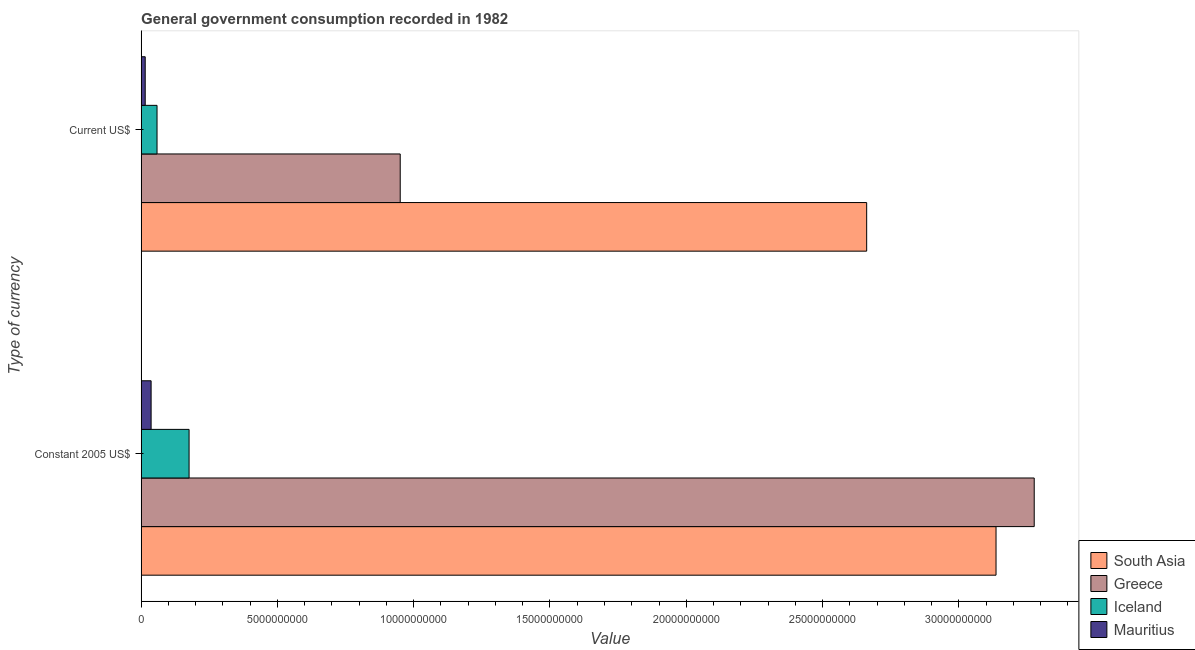How many different coloured bars are there?
Offer a terse response. 4. Are the number of bars on each tick of the Y-axis equal?
Provide a succinct answer. Yes. What is the label of the 2nd group of bars from the top?
Provide a succinct answer. Constant 2005 US$. What is the value consumed in current us$ in South Asia?
Your answer should be very brief. 2.66e+1. Across all countries, what is the maximum value consumed in constant 2005 us$?
Your answer should be very brief. 3.28e+1. Across all countries, what is the minimum value consumed in current us$?
Offer a terse response. 1.49e+08. In which country was the value consumed in constant 2005 us$ minimum?
Make the answer very short. Mauritius. What is the total value consumed in constant 2005 us$ in the graph?
Your answer should be compact. 6.63e+1. What is the difference between the value consumed in current us$ in Mauritius and that in Iceland?
Offer a terse response. -4.33e+08. What is the difference between the value consumed in current us$ in South Asia and the value consumed in constant 2005 us$ in Iceland?
Your answer should be compact. 2.49e+1. What is the average value consumed in current us$ per country?
Offer a terse response. 9.21e+09. What is the difference between the value consumed in current us$ and value consumed in constant 2005 us$ in Greece?
Provide a succinct answer. -2.33e+1. What is the ratio of the value consumed in current us$ in Greece to that in South Asia?
Keep it short and to the point. 0.36. Is the value consumed in constant 2005 us$ in Iceland less than that in South Asia?
Your response must be concise. Yes. In how many countries, is the value consumed in constant 2005 us$ greater than the average value consumed in constant 2005 us$ taken over all countries?
Provide a succinct answer. 2. What does the 3rd bar from the top in Constant 2005 US$ represents?
Make the answer very short. Greece. Are all the bars in the graph horizontal?
Offer a terse response. Yes. How many countries are there in the graph?
Your response must be concise. 4. What is the difference between two consecutive major ticks on the X-axis?
Make the answer very short. 5.00e+09. Are the values on the major ticks of X-axis written in scientific E-notation?
Ensure brevity in your answer.  No. Does the graph contain any zero values?
Keep it short and to the point. No. Does the graph contain grids?
Make the answer very short. No. Where does the legend appear in the graph?
Offer a very short reply. Bottom right. How are the legend labels stacked?
Your response must be concise. Vertical. What is the title of the graph?
Your answer should be very brief. General government consumption recorded in 1982. What is the label or title of the X-axis?
Provide a short and direct response. Value. What is the label or title of the Y-axis?
Your response must be concise. Type of currency. What is the Value in South Asia in Constant 2005 US$?
Make the answer very short. 3.14e+1. What is the Value of Greece in Constant 2005 US$?
Make the answer very short. 3.28e+1. What is the Value in Iceland in Constant 2005 US$?
Your response must be concise. 1.76e+09. What is the Value of Mauritius in Constant 2005 US$?
Provide a short and direct response. 3.66e+08. What is the Value in South Asia in Current US$?
Provide a succinct answer. 2.66e+1. What is the Value of Greece in Current US$?
Keep it short and to the point. 9.51e+09. What is the Value of Iceland in Current US$?
Offer a terse response. 5.83e+08. What is the Value of Mauritius in Current US$?
Provide a succinct answer. 1.49e+08. Across all Type of currency, what is the maximum Value in South Asia?
Give a very brief answer. 3.14e+1. Across all Type of currency, what is the maximum Value of Greece?
Provide a succinct answer. 3.28e+1. Across all Type of currency, what is the maximum Value in Iceland?
Ensure brevity in your answer.  1.76e+09. Across all Type of currency, what is the maximum Value in Mauritius?
Your answer should be very brief. 3.66e+08. Across all Type of currency, what is the minimum Value of South Asia?
Your answer should be very brief. 2.66e+1. Across all Type of currency, what is the minimum Value in Greece?
Make the answer very short. 9.51e+09. Across all Type of currency, what is the minimum Value in Iceland?
Give a very brief answer. 5.83e+08. Across all Type of currency, what is the minimum Value in Mauritius?
Your response must be concise. 1.49e+08. What is the total Value of South Asia in the graph?
Ensure brevity in your answer.  5.80e+1. What is the total Value in Greece in the graph?
Provide a short and direct response. 4.23e+1. What is the total Value in Iceland in the graph?
Your response must be concise. 2.34e+09. What is the total Value in Mauritius in the graph?
Offer a terse response. 5.15e+08. What is the difference between the Value in South Asia in Constant 2005 US$ and that in Current US$?
Provide a succinct answer. 4.75e+09. What is the difference between the Value in Greece in Constant 2005 US$ and that in Current US$?
Give a very brief answer. 2.33e+1. What is the difference between the Value in Iceland in Constant 2005 US$ and that in Current US$?
Give a very brief answer. 1.18e+09. What is the difference between the Value in Mauritius in Constant 2005 US$ and that in Current US$?
Offer a very short reply. 2.16e+08. What is the difference between the Value of South Asia in Constant 2005 US$ and the Value of Greece in Current US$?
Give a very brief answer. 2.19e+1. What is the difference between the Value of South Asia in Constant 2005 US$ and the Value of Iceland in Current US$?
Offer a very short reply. 3.08e+1. What is the difference between the Value in South Asia in Constant 2005 US$ and the Value in Mauritius in Current US$?
Your answer should be compact. 3.12e+1. What is the difference between the Value of Greece in Constant 2005 US$ and the Value of Iceland in Current US$?
Offer a very short reply. 3.22e+1. What is the difference between the Value in Greece in Constant 2005 US$ and the Value in Mauritius in Current US$?
Make the answer very short. 3.26e+1. What is the difference between the Value in Iceland in Constant 2005 US$ and the Value in Mauritius in Current US$?
Keep it short and to the point. 1.61e+09. What is the average Value in South Asia per Type of currency?
Offer a very short reply. 2.90e+1. What is the average Value of Greece per Type of currency?
Offer a terse response. 2.11e+1. What is the average Value of Iceland per Type of currency?
Ensure brevity in your answer.  1.17e+09. What is the average Value of Mauritius per Type of currency?
Provide a short and direct response. 2.57e+08. What is the difference between the Value of South Asia and Value of Greece in Constant 2005 US$?
Offer a terse response. -1.40e+09. What is the difference between the Value of South Asia and Value of Iceland in Constant 2005 US$?
Offer a very short reply. 2.96e+1. What is the difference between the Value in South Asia and Value in Mauritius in Constant 2005 US$?
Your answer should be very brief. 3.10e+1. What is the difference between the Value of Greece and Value of Iceland in Constant 2005 US$?
Your answer should be very brief. 3.10e+1. What is the difference between the Value in Greece and Value in Mauritius in Constant 2005 US$?
Give a very brief answer. 3.24e+1. What is the difference between the Value of Iceland and Value of Mauritius in Constant 2005 US$?
Keep it short and to the point. 1.39e+09. What is the difference between the Value in South Asia and Value in Greece in Current US$?
Ensure brevity in your answer.  1.71e+1. What is the difference between the Value in South Asia and Value in Iceland in Current US$?
Provide a short and direct response. 2.60e+1. What is the difference between the Value in South Asia and Value in Mauritius in Current US$?
Your response must be concise. 2.65e+1. What is the difference between the Value of Greece and Value of Iceland in Current US$?
Your response must be concise. 8.92e+09. What is the difference between the Value in Greece and Value in Mauritius in Current US$?
Keep it short and to the point. 9.36e+09. What is the difference between the Value of Iceland and Value of Mauritius in Current US$?
Offer a terse response. 4.33e+08. What is the ratio of the Value of South Asia in Constant 2005 US$ to that in Current US$?
Provide a succinct answer. 1.18. What is the ratio of the Value of Greece in Constant 2005 US$ to that in Current US$?
Your answer should be compact. 3.45. What is the ratio of the Value of Iceland in Constant 2005 US$ to that in Current US$?
Keep it short and to the point. 3.02. What is the ratio of the Value of Mauritius in Constant 2005 US$ to that in Current US$?
Your response must be concise. 2.45. What is the difference between the highest and the second highest Value in South Asia?
Your answer should be very brief. 4.75e+09. What is the difference between the highest and the second highest Value of Greece?
Give a very brief answer. 2.33e+1. What is the difference between the highest and the second highest Value of Iceland?
Your answer should be compact. 1.18e+09. What is the difference between the highest and the second highest Value of Mauritius?
Provide a short and direct response. 2.16e+08. What is the difference between the highest and the lowest Value in South Asia?
Provide a succinct answer. 4.75e+09. What is the difference between the highest and the lowest Value of Greece?
Give a very brief answer. 2.33e+1. What is the difference between the highest and the lowest Value of Iceland?
Give a very brief answer. 1.18e+09. What is the difference between the highest and the lowest Value of Mauritius?
Your answer should be compact. 2.16e+08. 